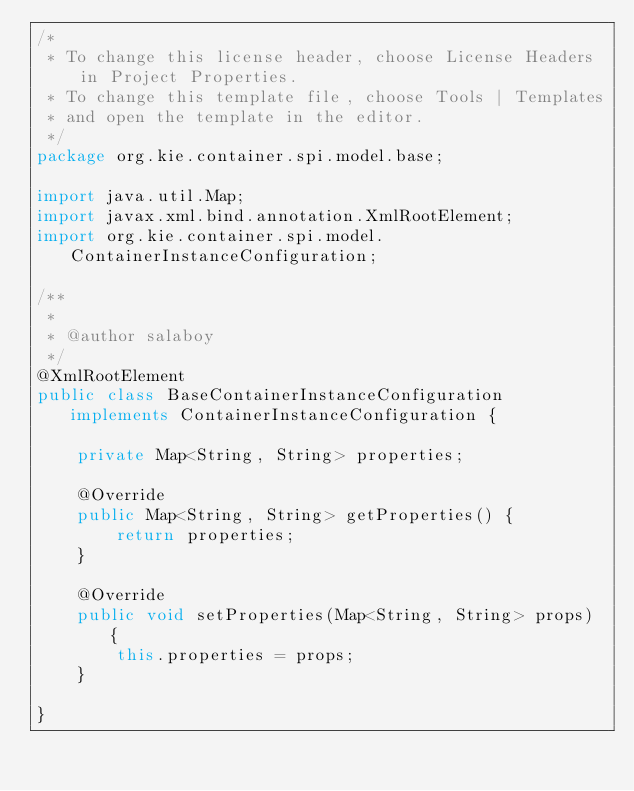Convert code to text. <code><loc_0><loc_0><loc_500><loc_500><_Java_>/*
 * To change this license header, choose License Headers in Project Properties.
 * To change this template file, choose Tools | Templates
 * and open the template in the editor.
 */
package org.kie.container.spi.model.base;

import java.util.Map;
import javax.xml.bind.annotation.XmlRootElement;
import org.kie.container.spi.model.ContainerInstanceConfiguration;

/**
 *
 * @author salaboy
 */
@XmlRootElement
public class BaseContainerInstanceConfiguration implements ContainerInstanceConfiguration {

    private Map<String, String> properties;

    @Override
    public Map<String, String> getProperties() {
        return properties;
    }

    @Override
    public void setProperties(Map<String, String> props) {
        this.properties = props;
    }

}
</code> 